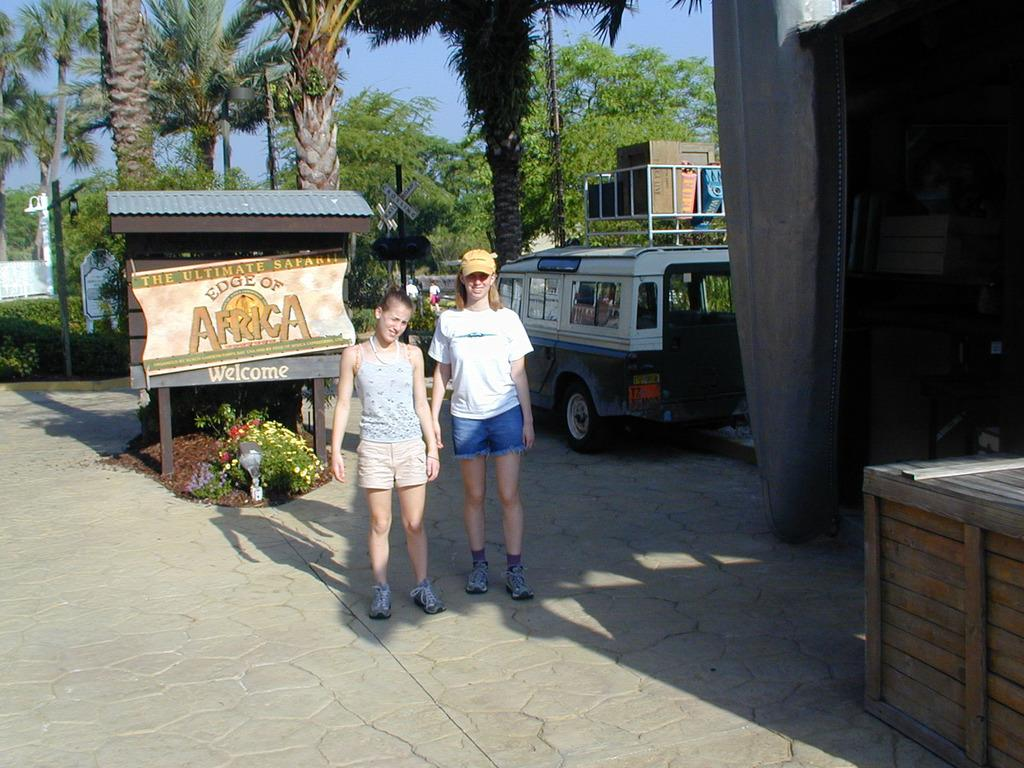<image>
Provide a brief description of the given image. Two young women are posing for a photo in front of a welcome sign for a safari in Africa. 